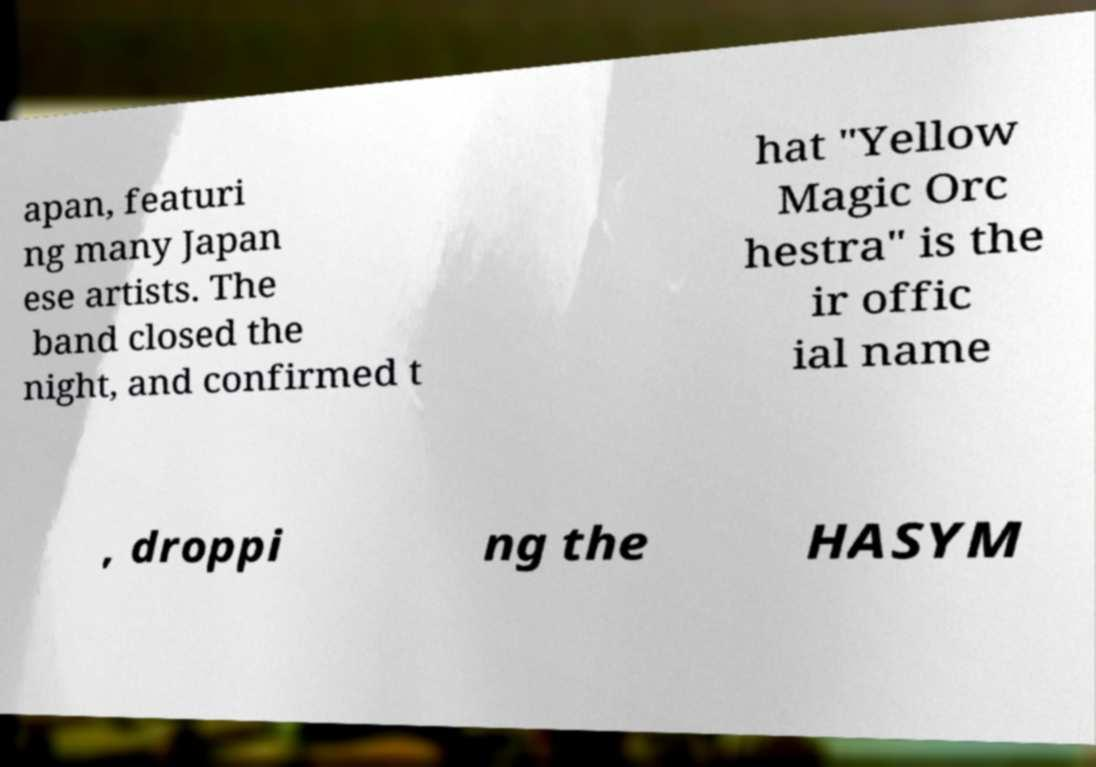Could you extract and type out the text from this image? apan, featuri ng many Japan ese artists. The band closed the night, and confirmed t hat "Yellow Magic Orc hestra" is the ir offic ial name , droppi ng the HASYM 